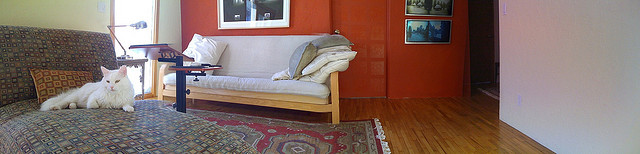How many sheep are laying in the grass? There are no sheep present in the image. What you see is a bright living room with a white cat lying on a patterned rug, beside a coffee table and a sofa. 